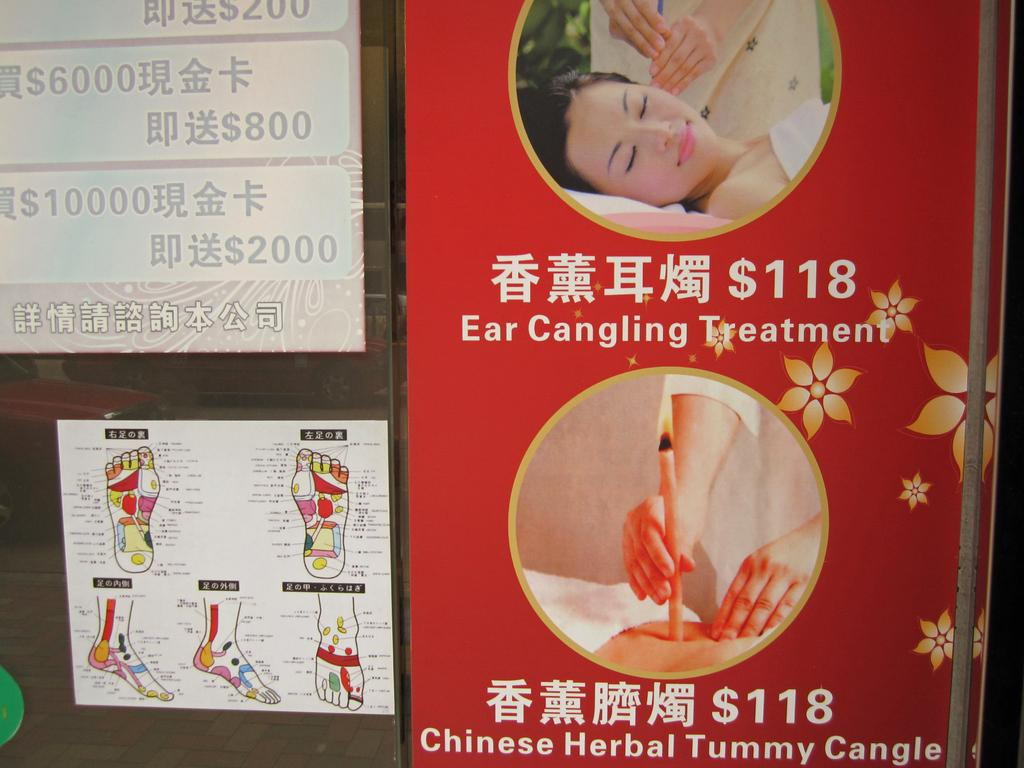What is on the glass in the image? There are posts on the glass in the image. Who or what can be seen in the image? There are persons visible in the image. What is on the right side of the image? There is a poster with text on the right side of the image. What is behind the glass in the image? There is an object behind the glass in the image. Can you see a kitty playing in the wilderness in the image? There is no kitty or wilderness present in the image. How many steps are visible in the image? There is no mention of steps in the provided facts, so it cannot be determined from the image. 